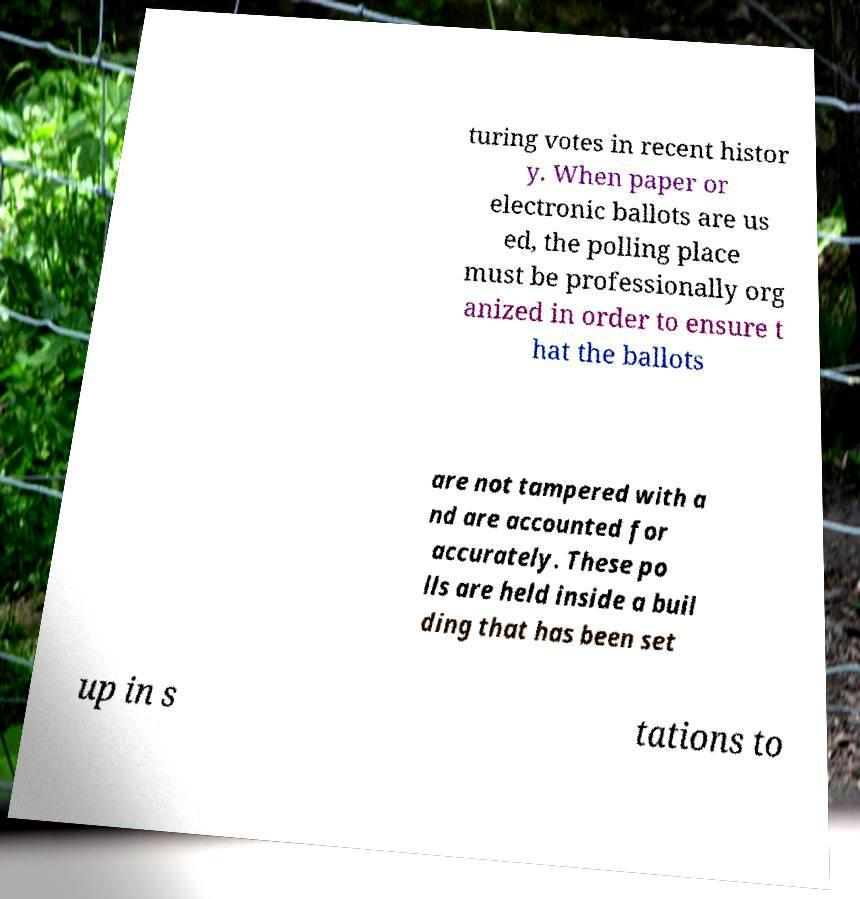Please identify and transcribe the text found in this image. turing votes in recent histor y. When paper or electronic ballots are us ed, the polling place must be professionally org anized in order to ensure t hat the ballots are not tampered with a nd are accounted for accurately. These po lls are held inside a buil ding that has been set up in s tations to 